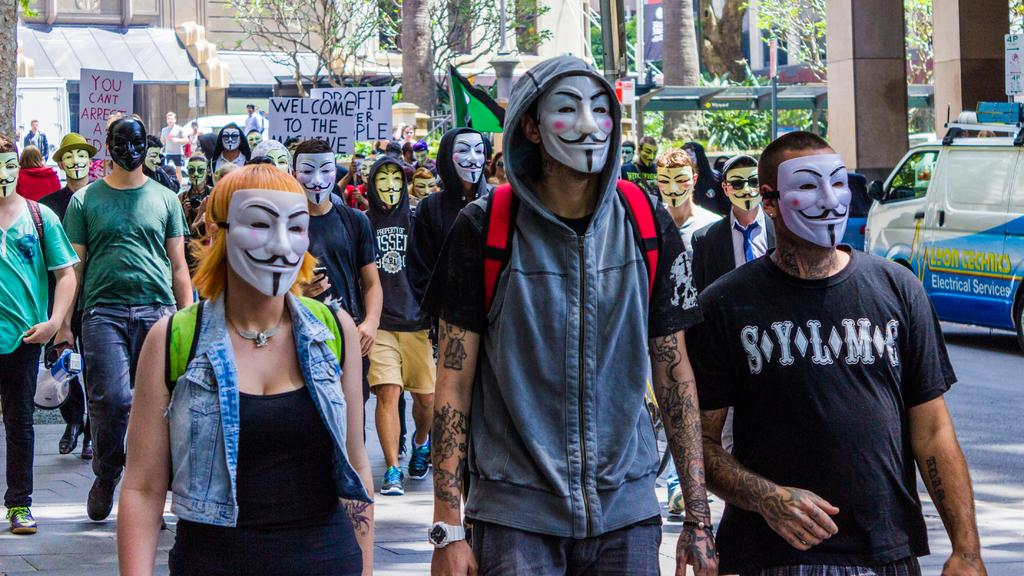Who can be seen in the image? There are people in the image. What are the people doing in the image? The people are walking on the street. What are the people wearing on their faces in the image? The people are wearing masks. What type of battle is taking place in the image? There is no battle present in the image; it features people walking on the street while wearing masks. What kind of cable can be seen connecting the people in the image? There is no cable connecting the people in the image; they are walking independently. 